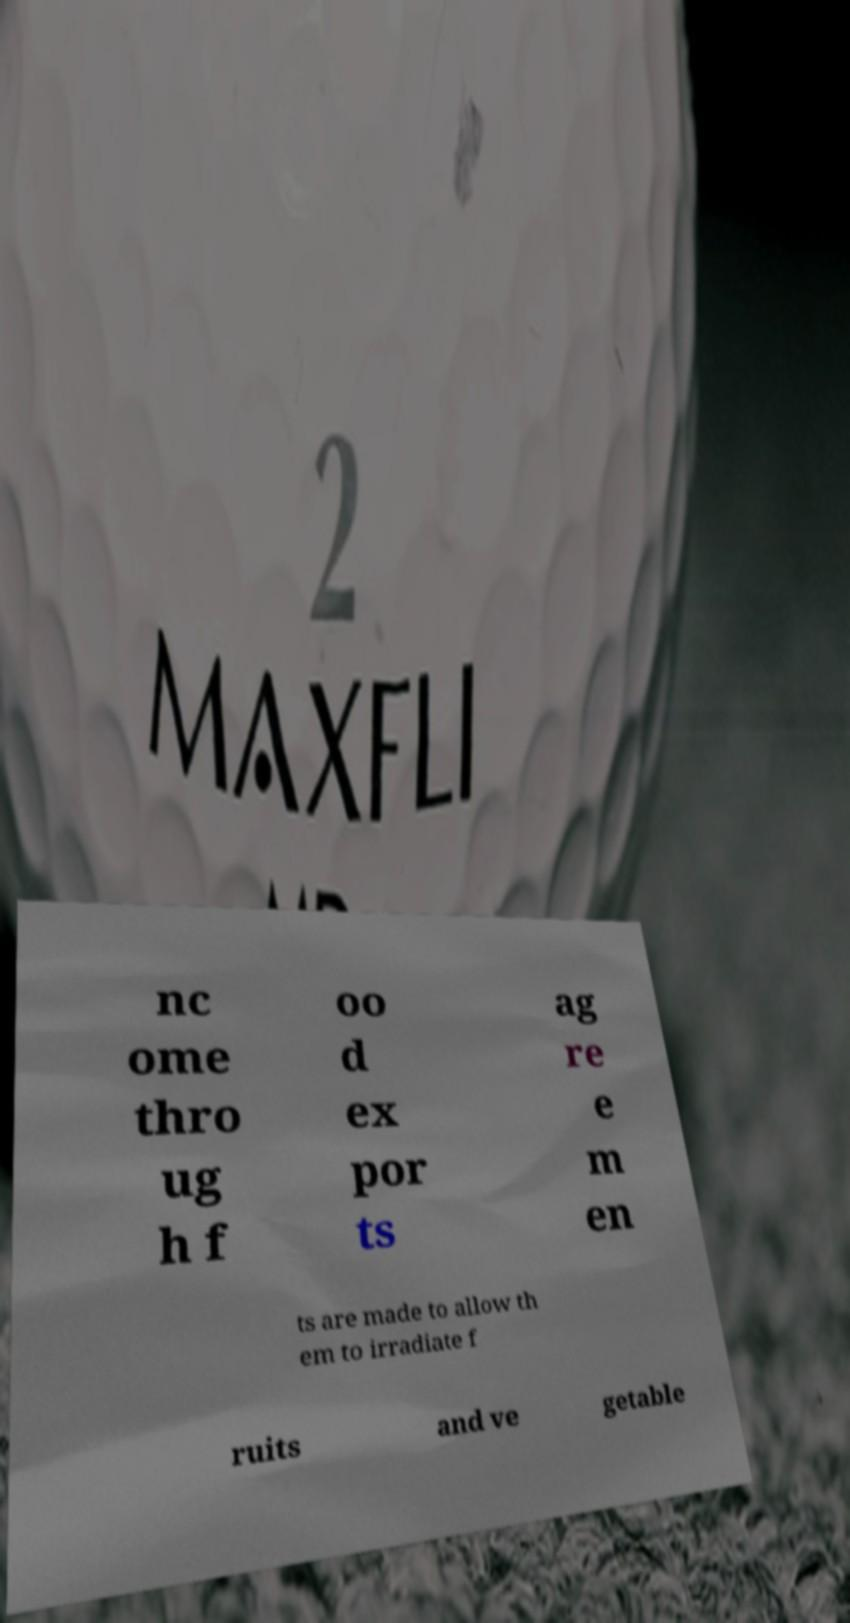Can you accurately transcribe the text from the provided image for me? nc ome thro ug h f oo d ex por ts ag re e m en ts are made to allow th em to irradiate f ruits and ve getable 